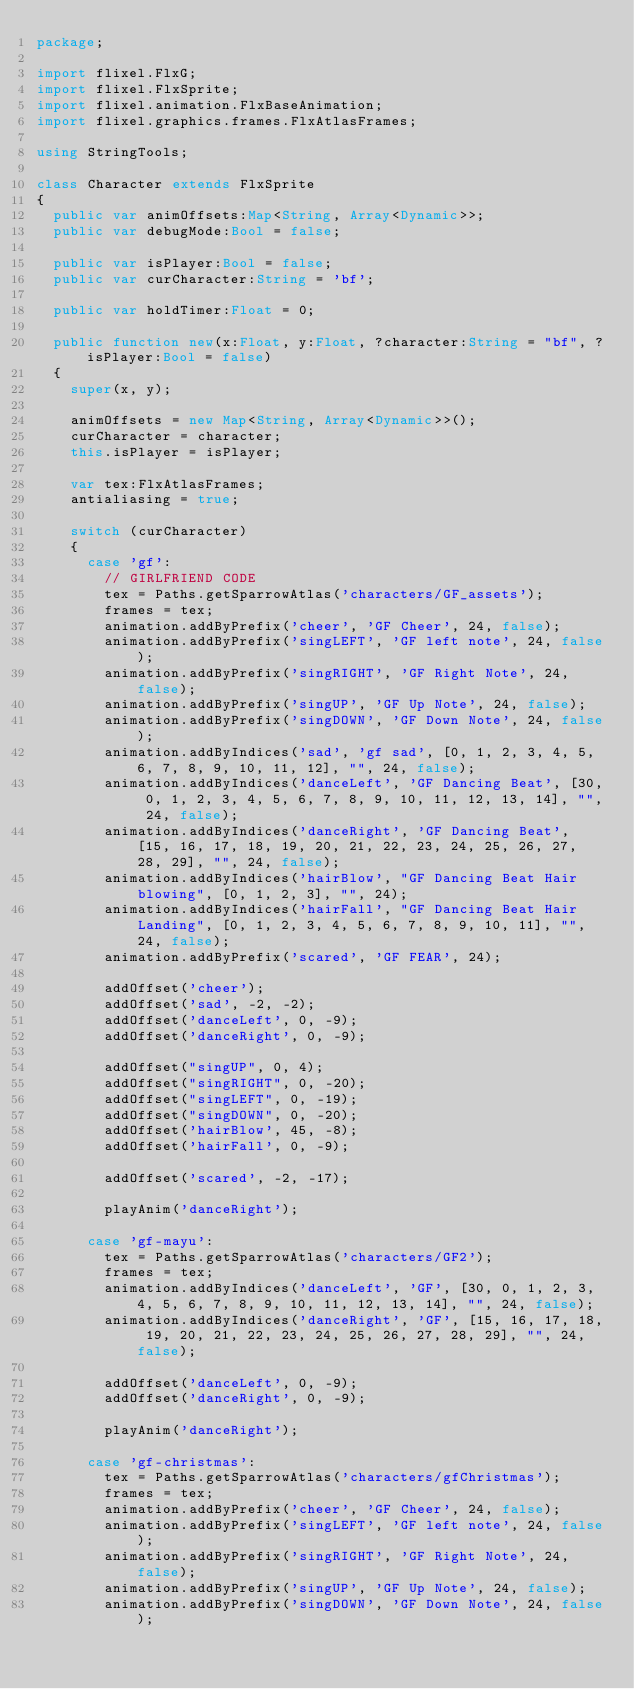<code> <loc_0><loc_0><loc_500><loc_500><_Haxe_>package;

import flixel.FlxG;
import flixel.FlxSprite;
import flixel.animation.FlxBaseAnimation;
import flixel.graphics.frames.FlxAtlasFrames;

using StringTools;

class Character extends FlxSprite
{
	public var animOffsets:Map<String, Array<Dynamic>>;
	public var debugMode:Bool = false;

	public var isPlayer:Bool = false;
	public var curCharacter:String = 'bf';

	public var holdTimer:Float = 0;

	public function new(x:Float, y:Float, ?character:String = "bf", ?isPlayer:Bool = false)
	{
		super(x, y);

		animOffsets = new Map<String, Array<Dynamic>>();
		curCharacter = character;
		this.isPlayer = isPlayer;

		var tex:FlxAtlasFrames;
		antialiasing = true;

		switch (curCharacter)
		{
			case 'gf':
				// GIRLFRIEND CODE
				tex = Paths.getSparrowAtlas('characters/GF_assets');
				frames = tex;
				animation.addByPrefix('cheer', 'GF Cheer', 24, false);
				animation.addByPrefix('singLEFT', 'GF left note', 24, false);
				animation.addByPrefix('singRIGHT', 'GF Right Note', 24, false);
				animation.addByPrefix('singUP', 'GF Up Note', 24, false);
				animation.addByPrefix('singDOWN', 'GF Down Note', 24, false);
				animation.addByIndices('sad', 'gf sad', [0, 1, 2, 3, 4, 5, 6, 7, 8, 9, 10, 11, 12], "", 24, false);
				animation.addByIndices('danceLeft', 'GF Dancing Beat', [30, 0, 1, 2, 3, 4, 5, 6, 7, 8, 9, 10, 11, 12, 13, 14], "", 24, false);
				animation.addByIndices('danceRight', 'GF Dancing Beat', [15, 16, 17, 18, 19, 20, 21, 22, 23, 24, 25, 26, 27, 28, 29], "", 24, false);
				animation.addByIndices('hairBlow', "GF Dancing Beat Hair blowing", [0, 1, 2, 3], "", 24);
				animation.addByIndices('hairFall', "GF Dancing Beat Hair Landing", [0, 1, 2, 3, 4, 5, 6, 7, 8, 9, 10, 11], "", 24, false);
				animation.addByPrefix('scared', 'GF FEAR', 24);

				addOffset('cheer');
				addOffset('sad', -2, -2);
				addOffset('danceLeft', 0, -9);
				addOffset('danceRight', 0, -9);

				addOffset("singUP", 0, 4);
				addOffset("singRIGHT", 0, -20);
				addOffset("singLEFT", 0, -19);
				addOffset("singDOWN", 0, -20);
				addOffset('hairBlow', 45, -8);
				addOffset('hairFall', 0, -9);

				addOffset('scared', -2, -17);

				playAnim('danceRight');
				
			case 'gf-mayu':
				tex = Paths.getSparrowAtlas('characters/GF2');
				frames = tex;
				animation.addByIndices('danceLeft', 'GF', [30, 0, 1, 2, 3, 4, 5, 6, 7, 8, 9, 10, 11, 12, 13, 14], "", 24, false);
				animation.addByIndices('danceRight', 'GF', [15, 16, 17, 18, 19, 20, 21, 22, 23, 24, 25, 26, 27, 28, 29], "", 24, false);

				addOffset('danceLeft', 0, -9);
				addOffset('danceRight', 0, -9);

				playAnim('danceRight');

			case 'gf-christmas':
				tex = Paths.getSparrowAtlas('characters/gfChristmas');
				frames = tex;
				animation.addByPrefix('cheer', 'GF Cheer', 24, false);
				animation.addByPrefix('singLEFT', 'GF left note', 24, false);
				animation.addByPrefix('singRIGHT', 'GF Right Note', 24, false);
				animation.addByPrefix('singUP', 'GF Up Note', 24, false);
				animation.addByPrefix('singDOWN', 'GF Down Note', 24, false);</code> 